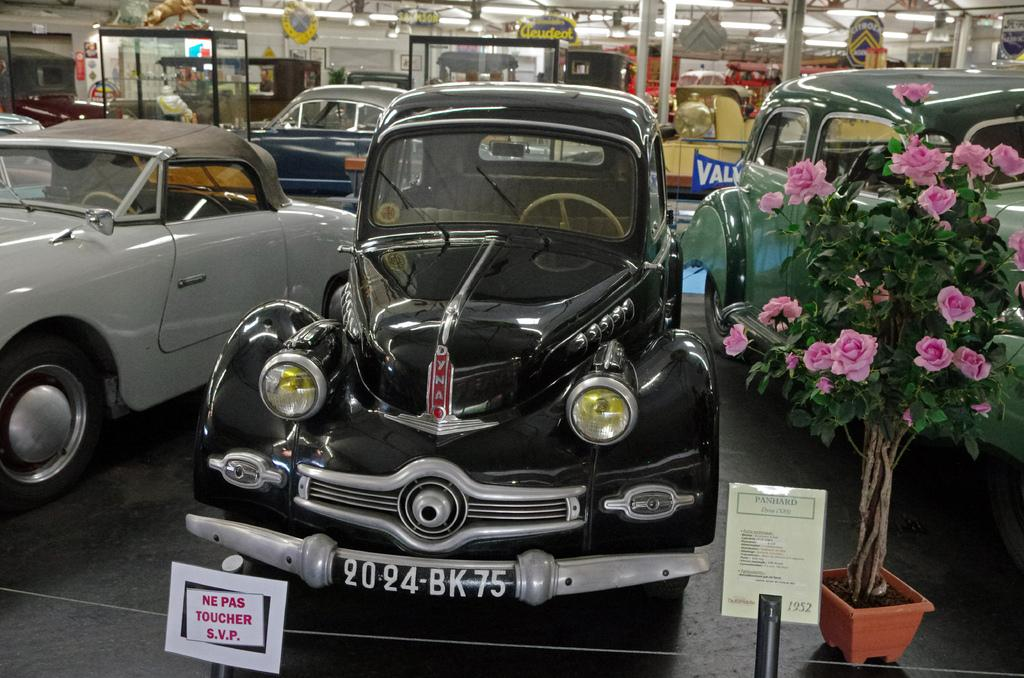What structures can be seen in the image? There are posts and poles in the image. What is on the floor in the image? There are vehicles on the floor in the image. What type of plant is present in the image? There is a house plant with flowers in the image. What can be seen in the background of the image? In the background, there are name boards, glass boxes, lights, and some unspecified objects. What type of reward is hanging from the neck of the head in the image? There is no neck or head present in the image, and therefore no reward can be observed. 